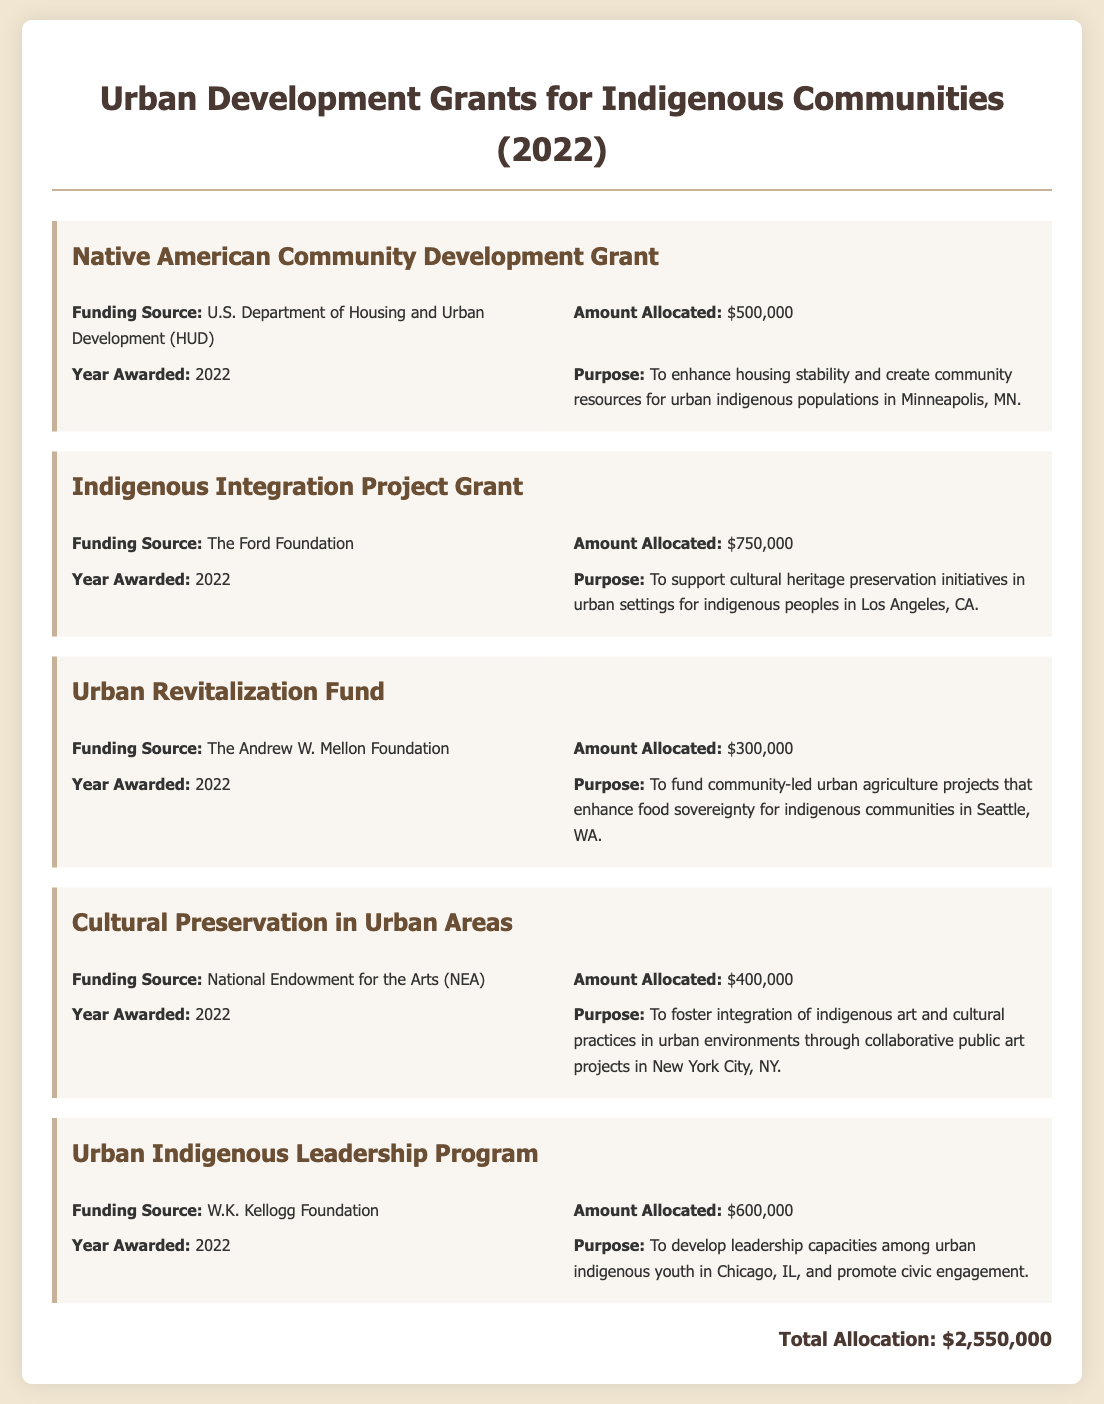What is the total allocation for grants? The total allocation is the sum of all individual grant amounts awarded, which equals $500,000 + $750,000 + $300,000 + $400,000 + $600,000.
Answer: $2,550,000 How much did the U.S. Department of Housing and Urban Development award? This amount corresponds to the specific grant named "Native American Community Development Grant."
Answer: $500,000 What is the purpose of the "Indigenous Integration Project Grant"? This purpose is clearly stated in the grant description and focuses on cultural heritage preservation for indigenous peoples.
Answer: To support cultural heritage preservation initiatives in urban settings for indigenous peoples in Los Angeles, CA Which foundation awarded $600,000 for indigenous community projects? This question requires recognizing the funding source linked to the specific grant amount among the listed grants.
Answer: W.K. Kellogg Foundation What year were these grants awarded? All grants included in the document mention the same year in which they were awarded.
Answer: 2022 Which city is associated with the "Urban Revitalization Fund"? The document provides a specific location for this grant within its purpose.
Answer: Seattle What is the name of the program aimed at developing leadership capacities? The question seeks to identify the specific title of the grant related to leadership.
Answer: Urban Indigenous Leadership Program Which grant was funded by The Ford Foundation? This question seeks to identify which specific grant corresponds to this funding source.
Answer: Indigenous Integration Project Grant 